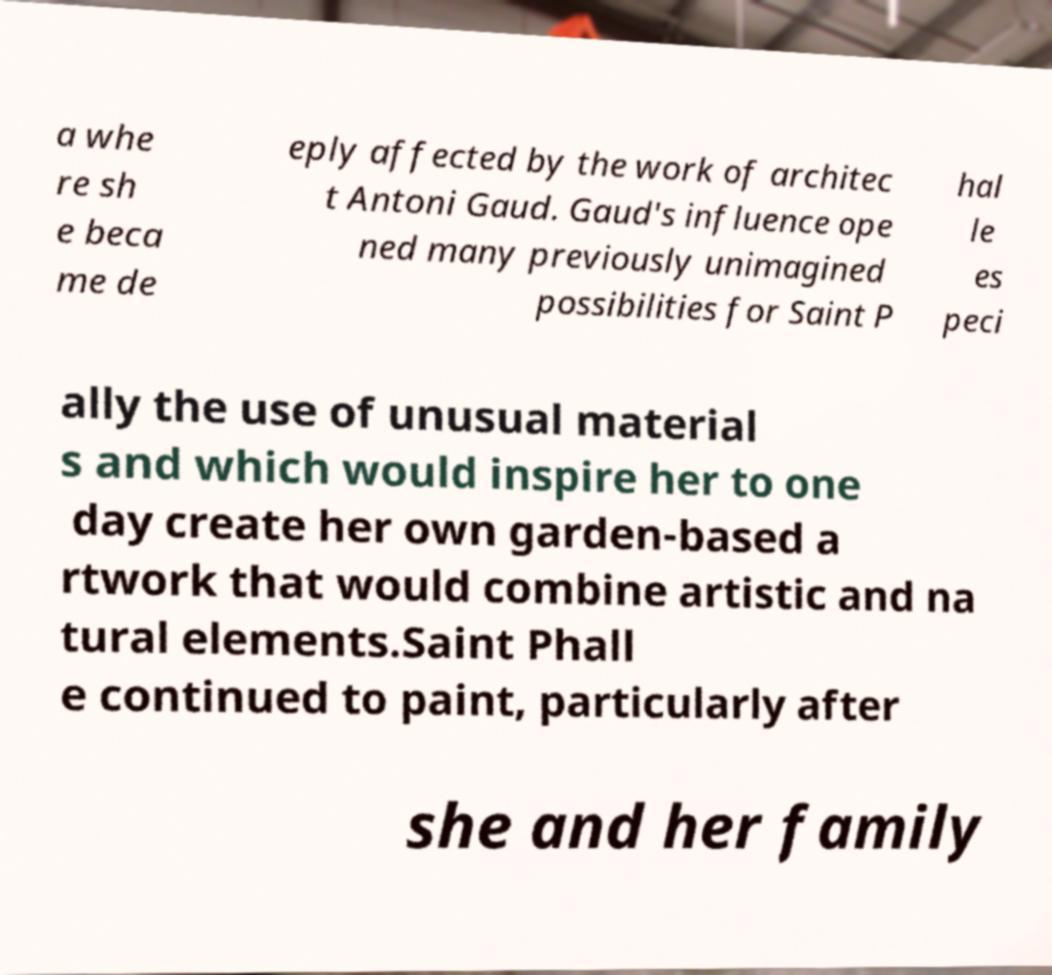Could you assist in decoding the text presented in this image and type it out clearly? a whe re sh e beca me de eply affected by the work of architec t Antoni Gaud. Gaud's influence ope ned many previously unimagined possibilities for Saint P hal le es peci ally the use of unusual material s and which would inspire her to one day create her own garden-based a rtwork that would combine artistic and na tural elements.Saint Phall e continued to paint, particularly after she and her family 